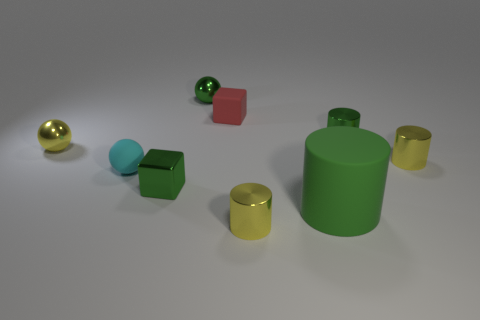There is a small cylinder that is in front of the yellow metal cylinder that is behind the green rubber thing; what is its material?
Ensure brevity in your answer.  Metal. Are there an equal number of small red cubes to the left of the small red thing and matte blocks in front of the green metal cylinder?
Provide a short and direct response. Yes. Is the small red matte thing the same shape as the small cyan rubber object?
Keep it short and to the point. No. There is a green thing that is on the right side of the green metal block and in front of the small cyan rubber thing; what is its material?
Ensure brevity in your answer.  Rubber. What number of other rubber things have the same shape as the tiny red thing?
Offer a very short reply. 0. There is a rubber thing that is on the left side of the small cube behind the tiny ball on the left side of the cyan matte ball; what is its size?
Offer a very short reply. Small. Is the number of tiny cubes that are behind the yellow metallic ball greater than the number of tiny green shiny cylinders?
Your answer should be compact. No. Are any matte spheres visible?
Your answer should be compact. Yes. What number of red things are the same size as the matte cylinder?
Your answer should be compact. 0. Is the number of small rubber spheres that are in front of the red matte cube greater than the number of shiny cylinders that are behind the big rubber cylinder?
Provide a succinct answer. No. 